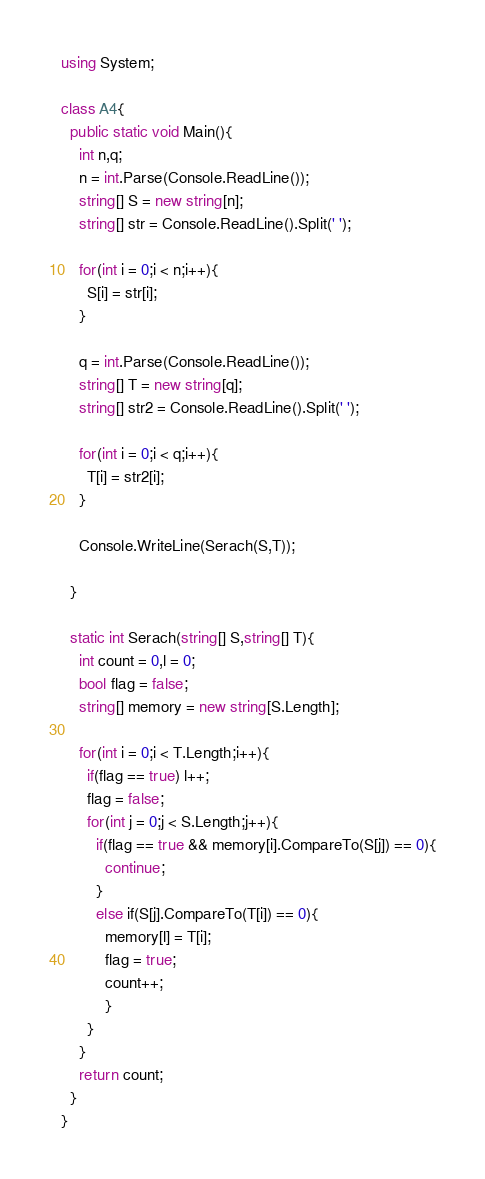<code> <loc_0><loc_0><loc_500><loc_500><_C#_>using System;

class A4{
  public static void Main(){
    int n,q;
    n = int.Parse(Console.ReadLine());
    string[] S = new string[n];
    string[] str = Console.ReadLine().Split(' ');

    for(int i = 0;i < n;i++){
      S[i] = str[i];
    }

    q = int.Parse(Console.ReadLine());
    string[] T = new string[q];
    string[] str2 = Console.ReadLine().Split(' ');

    for(int i = 0;i < q;i++){
      T[i] = str2[i];
    }

    Console.WriteLine(Serach(S,T));

  }

  static int Serach(string[] S,string[] T){
    int count = 0,l = 0;
    bool flag = false;
    string[] memory = new string[S.Length];

    for(int i = 0;i < T.Length;i++){
      if(flag == true) l++;
      flag = false;
      for(int j = 0;j < S.Length;j++){
        if(flag == true && memory[i].CompareTo(S[j]) == 0){
          continue;
        }
        else if(S[j].CompareTo(T[i]) == 0){
          memory[l] = T[i];
          flag = true;
          count++;
          }
      }
    }
    return count;
  }
}
</code> 